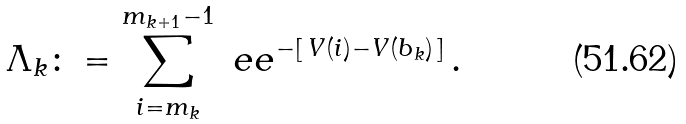Convert formula to latex. <formula><loc_0><loc_0><loc_500><loc_500>\Lambda _ { k } \colon = \sum _ { i = m _ { k } } ^ { m _ { k + 1 } - 1 } \ e e ^ { - [ \, V ( i ) - V ( b _ { k } ) \, ] } \, .</formula> 